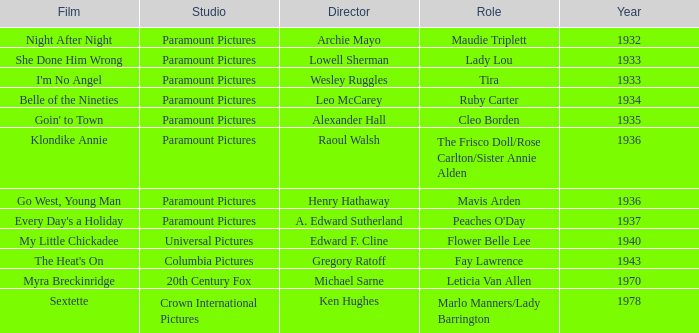What is the Year of the Film Belle of the Nineties? 1934.0. Would you be able to parse every entry in this table? {'header': ['Film', 'Studio', 'Director', 'Role', 'Year'], 'rows': [['Night After Night', 'Paramount Pictures', 'Archie Mayo', 'Maudie Triplett', '1932'], ['She Done Him Wrong', 'Paramount Pictures', 'Lowell Sherman', 'Lady Lou', '1933'], ["I'm No Angel", 'Paramount Pictures', 'Wesley Ruggles', 'Tira', '1933'], ['Belle of the Nineties', 'Paramount Pictures', 'Leo McCarey', 'Ruby Carter', '1934'], ["Goin' to Town", 'Paramount Pictures', 'Alexander Hall', 'Cleo Borden', '1935'], ['Klondike Annie', 'Paramount Pictures', 'Raoul Walsh', 'The Frisco Doll/Rose Carlton/Sister Annie Alden', '1936'], ['Go West, Young Man', 'Paramount Pictures', 'Henry Hathaway', 'Mavis Arden', '1936'], ["Every Day's a Holiday", 'Paramount Pictures', 'A. Edward Sutherland', "Peaches O'Day", '1937'], ['My Little Chickadee', 'Universal Pictures', 'Edward F. Cline', 'Flower Belle Lee', '1940'], ["The Heat's On", 'Columbia Pictures', 'Gregory Ratoff', 'Fay Lawrence', '1943'], ['Myra Breckinridge', '20th Century Fox', 'Michael Sarne', 'Leticia Van Allen', '1970'], ['Sextette', 'Crown International Pictures', 'Ken Hughes', 'Marlo Manners/Lady Barrington', '1978']]} 